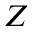<formula> <loc_0><loc_0><loc_500><loc_500>Z</formula> 